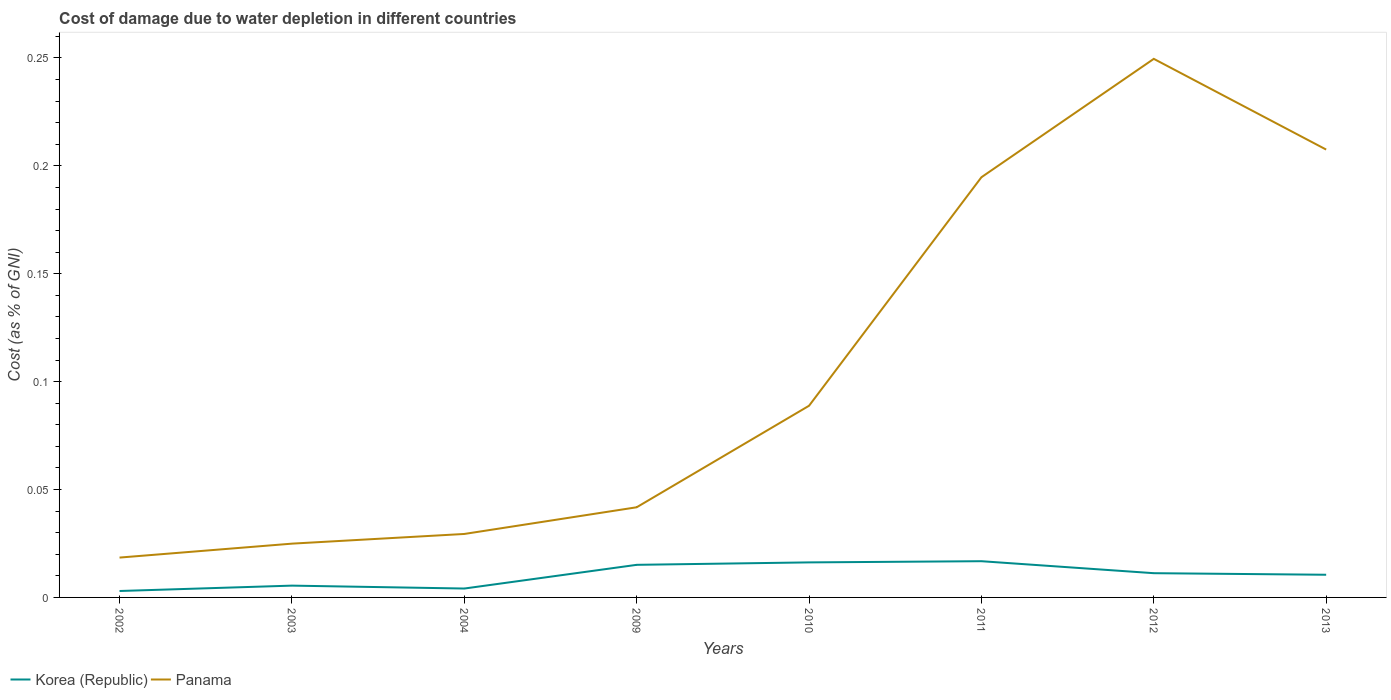How many different coloured lines are there?
Keep it short and to the point. 2. Across all years, what is the maximum cost of damage caused due to water depletion in Korea (Republic)?
Offer a very short reply. 0. What is the total cost of damage caused due to water depletion in Panama in the graph?
Offer a very short reply. -0.12. What is the difference between the highest and the second highest cost of damage caused due to water depletion in Panama?
Give a very brief answer. 0.23. What is the difference between the highest and the lowest cost of damage caused due to water depletion in Panama?
Offer a very short reply. 3. How many lines are there?
Keep it short and to the point. 2. How many years are there in the graph?
Offer a very short reply. 8. What is the difference between two consecutive major ticks on the Y-axis?
Provide a succinct answer. 0.05. Does the graph contain grids?
Make the answer very short. No. Where does the legend appear in the graph?
Provide a succinct answer. Bottom left. What is the title of the graph?
Ensure brevity in your answer.  Cost of damage due to water depletion in different countries. Does "South Asia" appear as one of the legend labels in the graph?
Provide a succinct answer. No. What is the label or title of the X-axis?
Provide a short and direct response. Years. What is the label or title of the Y-axis?
Your answer should be very brief. Cost (as % of GNI). What is the Cost (as % of GNI) in Korea (Republic) in 2002?
Offer a very short reply. 0. What is the Cost (as % of GNI) of Panama in 2002?
Your response must be concise. 0.02. What is the Cost (as % of GNI) in Korea (Republic) in 2003?
Your response must be concise. 0.01. What is the Cost (as % of GNI) of Panama in 2003?
Make the answer very short. 0.02. What is the Cost (as % of GNI) of Korea (Republic) in 2004?
Offer a very short reply. 0. What is the Cost (as % of GNI) in Panama in 2004?
Your answer should be very brief. 0.03. What is the Cost (as % of GNI) in Korea (Republic) in 2009?
Your response must be concise. 0.02. What is the Cost (as % of GNI) in Panama in 2009?
Give a very brief answer. 0.04. What is the Cost (as % of GNI) of Korea (Republic) in 2010?
Give a very brief answer. 0.02. What is the Cost (as % of GNI) in Panama in 2010?
Keep it short and to the point. 0.09. What is the Cost (as % of GNI) in Korea (Republic) in 2011?
Offer a terse response. 0.02. What is the Cost (as % of GNI) in Panama in 2011?
Your answer should be compact. 0.19. What is the Cost (as % of GNI) in Korea (Republic) in 2012?
Keep it short and to the point. 0.01. What is the Cost (as % of GNI) of Panama in 2012?
Provide a succinct answer. 0.25. What is the Cost (as % of GNI) of Korea (Republic) in 2013?
Offer a very short reply. 0.01. What is the Cost (as % of GNI) in Panama in 2013?
Give a very brief answer. 0.21. Across all years, what is the maximum Cost (as % of GNI) of Korea (Republic)?
Keep it short and to the point. 0.02. Across all years, what is the maximum Cost (as % of GNI) of Panama?
Offer a terse response. 0.25. Across all years, what is the minimum Cost (as % of GNI) in Korea (Republic)?
Provide a short and direct response. 0. Across all years, what is the minimum Cost (as % of GNI) in Panama?
Make the answer very short. 0.02. What is the total Cost (as % of GNI) in Korea (Republic) in the graph?
Your answer should be very brief. 0.08. What is the total Cost (as % of GNI) in Panama in the graph?
Give a very brief answer. 0.86. What is the difference between the Cost (as % of GNI) in Korea (Republic) in 2002 and that in 2003?
Your answer should be compact. -0. What is the difference between the Cost (as % of GNI) in Panama in 2002 and that in 2003?
Ensure brevity in your answer.  -0.01. What is the difference between the Cost (as % of GNI) in Korea (Republic) in 2002 and that in 2004?
Ensure brevity in your answer.  -0. What is the difference between the Cost (as % of GNI) in Panama in 2002 and that in 2004?
Provide a short and direct response. -0.01. What is the difference between the Cost (as % of GNI) of Korea (Republic) in 2002 and that in 2009?
Keep it short and to the point. -0.01. What is the difference between the Cost (as % of GNI) in Panama in 2002 and that in 2009?
Provide a short and direct response. -0.02. What is the difference between the Cost (as % of GNI) in Korea (Republic) in 2002 and that in 2010?
Offer a very short reply. -0.01. What is the difference between the Cost (as % of GNI) in Panama in 2002 and that in 2010?
Your answer should be compact. -0.07. What is the difference between the Cost (as % of GNI) in Korea (Republic) in 2002 and that in 2011?
Make the answer very short. -0.01. What is the difference between the Cost (as % of GNI) in Panama in 2002 and that in 2011?
Ensure brevity in your answer.  -0.18. What is the difference between the Cost (as % of GNI) of Korea (Republic) in 2002 and that in 2012?
Keep it short and to the point. -0.01. What is the difference between the Cost (as % of GNI) in Panama in 2002 and that in 2012?
Offer a terse response. -0.23. What is the difference between the Cost (as % of GNI) of Korea (Republic) in 2002 and that in 2013?
Your answer should be very brief. -0.01. What is the difference between the Cost (as % of GNI) in Panama in 2002 and that in 2013?
Offer a terse response. -0.19. What is the difference between the Cost (as % of GNI) of Korea (Republic) in 2003 and that in 2004?
Provide a succinct answer. 0. What is the difference between the Cost (as % of GNI) in Panama in 2003 and that in 2004?
Your answer should be compact. -0. What is the difference between the Cost (as % of GNI) of Korea (Republic) in 2003 and that in 2009?
Offer a terse response. -0.01. What is the difference between the Cost (as % of GNI) in Panama in 2003 and that in 2009?
Ensure brevity in your answer.  -0.02. What is the difference between the Cost (as % of GNI) of Korea (Republic) in 2003 and that in 2010?
Give a very brief answer. -0.01. What is the difference between the Cost (as % of GNI) in Panama in 2003 and that in 2010?
Offer a very short reply. -0.06. What is the difference between the Cost (as % of GNI) in Korea (Republic) in 2003 and that in 2011?
Your answer should be compact. -0.01. What is the difference between the Cost (as % of GNI) in Panama in 2003 and that in 2011?
Your answer should be very brief. -0.17. What is the difference between the Cost (as % of GNI) in Korea (Republic) in 2003 and that in 2012?
Make the answer very short. -0.01. What is the difference between the Cost (as % of GNI) in Panama in 2003 and that in 2012?
Make the answer very short. -0.22. What is the difference between the Cost (as % of GNI) of Korea (Republic) in 2003 and that in 2013?
Give a very brief answer. -0.01. What is the difference between the Cost (as % of GNI) in Panama in 2003 and that in 2013?
Offer a very short reply. -0.18. What is the difference between the Cost (as % of GNI) of Korea (Republic) in 2004 and that in 2009?
Give a very brief answer. -0.01. What is the difference between the Cost (as % of GNI) of Panama in 2004 and that in 2009?
Make the answer very short. -0.01. What is the difference between the Cost (as % of GNI) in Korea (Republic) in 2004 and that in 2010?
Make the answer very short. -0.01. What is the difference between the Cost (as % of GNI) in Panama in 2004 and that in 2010?
Ensure brevity in your answer.  -0.06. What is the difference between the Cost (as % of GNI) of Korea (Republic) in 2004 and that in 2011?
Give a very brief answer. -0.01. What is the difference between the Cost (as % of GNI) of Panama in 2004 and that in 2011?
Provide a short and direct response. -0.17. What is the difference between the Cost (as % of GNI) of Korea (Republic) in 2004 and that in 2012?
Offer a very short reply. -0.01. What is the difference between the Cost (as % of GNI) of Panama in 2004 and that in 2012?
Give a very brief answer. -0.22. What is the difference between the Cost (as % of GNI) in Korea (Republic) in 2004 and that in 2013?
Offer a terse response. -0.01. What is the difference between the Cost (as % of GNI) of Panama in 2004 and that in 2013?
Your answer should be very brief. -0.18. What is the difference between the Cost (as % of GNI) in Korea (Republic) in 2009 and that in 2010?
Offer a terse response. -0. What is the difference between the Cost (as % of GNI) in Panama in 2009 and that in 2010?
Your answer should be very brief. -0.05. What is the difference between the Cost (as % of GNI) in Korea (Republic) in 2009 and that in 2011?
Make the answer very short. -0. What is the difference between the Cost (as % of GNI) in Panama in 2009 and that in 2011?
Your response must be concise. -0.15. What is the difference between the Cost (as % of GNI) of Korea (Republic) in 2009 and that in 2012?
Your answer should be very brief. 0. What is the difference between the Cost (as % of GNI) of Panama in 2009 and that in 2012?
Your response must be concise. -0.21. What is the difference between the Cost (as % of GNI) in Korea (Republic) in 2009 and that in 2013?
Make the answer very short. 0. What is the difference between the Cost (as % of GNI) of Panama in 2009 and that in 2013?
Provide a short and direct response. -0.17. What is the difference between the Cost (as % of GNI) of Korea (Republic) in 2010 and that in 2011?
Give a very brief answer. -0. What is the difference between the Cost (as % of GNI) of Panama in 2010 and that in 2011?
Offer a terse response. -0.11. What is the difference between the Cost (as % of GNI) in Korea (Republic) in 2010 and that in 2012?
Your response must be concise. 0.01. What is the difference between the Cost (as % of GNI) of Panama in 2010 and that in 2012?
Your answer should be compact. -0.16. What is the difference between the Cost (as % of GNI) of Korea (Republic) in 2010 and that in 2013?
Offer a terse response. 0.01. What is the difference between the Cost (as % of GNI) of Panama in 2010 and that in 2013?
Offer a terse response. -0.12. What is the difference between the Cost (as % of GNI) in Korea (Republic) in 2011 and that in 2012?
Ensure brevity in your answer.  0.01. What is the difference between the Cost (as % of GNI) in Panama in 2011 and that in 2012?
Your response must be concise. -0.05. What is the difference between the Cost (as % of GNI) in Korea (Republic) in 2011 and that in 2013?
Offer a terse response. 0.01. What is the difference between the Cost (as % of GNI) in Panama in 2011 and that in 2013?
Offer a terse response. -0.01. What is the difference between the Cost (as % of GNI) of Korea (Republic) in 2012 and that in 2013?
Your answer should be very brief. 0. What is the difference between the Cost (as % of GNI) in Panama in 2012 and that in 2013?
Keep it short and to the point. 0.04. What is the difference between the Cost (as % of GNI) of Korea (Republic) in 2002 and the Cost (as % of GNI) of Panama in 2003?
Give a very brief answer. -0.02. What is the difference between the Cost (as % of GNI) in Korea (Republic) in 2002 and the Cost (as % of GNI) in Panama in 2004?
Ensure brevity in your answer.  -0.03. What is the difference between the Cost (as % of GNI) of Korea (Republic) in 2002 and the Cost (as % of GNI) of Panama in 2009?
Provide a short and direct response. -0.04. What is the difference between the Cost (as % of GNI) in Korea (Republic) in 2002 and the Cost (as % of GNI) in Panama in 2010?
Offer a very short reply. -0.09. What is the difference between the Cost (as % of GNI) of Korea (Republic) in 2002 and the Cost (as % of GNI) of Panama in 2011?
Make the answer very short. -0.19. What is the difference between the Cost (as % of GNI) of Korea (Republic) in 2002 and the Cost (as % of GNI) of Panama in 2012?
Offer a very short reply. -0.25. What is the difference between the Cost (as % of GNI) of Korea (Republic) in 2002 and the Cost (as % of GNI) of Panama in 2013?
Keep it short and to the point. -0.2. What is the difference between the Cost (as % of GNI) of Korea (Republic) in 2003 and the Cost (as % of GNI) of Panama in 2004?
Your response must be concise. -0.02. What is the difference between the Cost (as % of GNI) of Korea (Republic) in 2003 and the Cost (as % of GNI) of Panama in 2009?
Offer a very short reply. -0.04. What is the difference between the Cost (as % of GNI) in Korea (Republic) in 2003 and the Cost (as % of GNI) in Panama in 2010?
Keep it short and to the point. -0.08. What is the difference between the Cost (as % of GNI) of Korea (Republic) in 2003 and the Cost (as % of GNI) of Panama in 2011?
Provide a short and direct response. -0.19. What is the difference between the Cost (as % of GNI) in Korea (Republic) in 2003 and the Cost (as % of GNI) in Panama in 2012?
Give a very brief answer. -0.24. What is the difference between the Cost (as % of GNI) in Korea (Republic) in 2003 and the Cost (as % of GNI) in Panama in 2013?
Ensure brevity in your answer.  -0.2. What is the difference between the Cost (as % of GNI) of Korea (Republic) in 2004 and the Cost (as % of GNI) of Panama in 2009?
Provide a short and direct response. -0.04. What is the difference between the Cost (as % of GNI) in Korea (Republic) in 2004 and the Cost (as % of GNI) in Panama in 2010?
Your answer should be very brief. -0.08. What is the difference between the Cost (as % of GNI) in Korea (Republic) in 2004 and the Cost (as % of GNI) in Panama in 2011?
Your answer should be compact. -0.19. What is the difference between the Cost (as % of GNI) in Korea (Republic) in 2004 and the Cost (as % of GNI) in Panama in 2012?
Provide a succinct answer. -0.25. What is the difference between the Cost (as % of GNI) of Korea (Republic) in 2004 and the Cost (as % of GNI) of Panama in 2013?
Offer a very short reply. -0.2. What is the difference between the Cost (as % of GNI) in Korea (Republic) in 2009 and the Cost (as % of GNI) in Panama in 2010?
Your answer should be compact. -0.07. What is the difference between the Cost (as % of GNI) in Korea (Republic) in 2009 and the Cost (as % of GNI) in Panama in 2011?
Make the answer very short. -0.18. What is the difference between the Cost (as % of GNI) of Korea (Republic) in 2009 and the Cost (as % of GNI) of Panama in 2012?
Provide a succinct answer. -0.23. What is the difference between the Cost (as % of GNI) in Korea (Republic) in 2009 and the Cost (as % of GNI) in Panama in 2013?
Offer a very short reply. -0.19. What is the difference between the Cost (as % of GNI) in Korea (Republic) in 2010 and the Cost (as % of GNI) in Panama in 2011?
Ensure brevity in your answer.  -0.18. What is the difference between the Cost (as % of GNI) in Korea (Republic) in 2010 and the Cost (as % of GNI) in Panama in 2012?
Make the answer very short. -0.23. What is the difference between the Cost (as % of GNI) in Korea (Republic) in 2010 and the Cost (as % of GNI) in Panama in 2013?
Provide a short and direct response. -0.19. What is the difference between the Cost (as % of GNI) of Korea (Republic) in 2011 and the Cost (as % of GNI) of Panama in 2012?
Make the answer very short. -0.23. What is the difference between the Cost (as % of GNI) in Korea (Republic) in 2011 and the Cost (as % of GNI) in Panama in 2013?
Your answer should be very brief. -0.19. What is the difference between the Cost (as % of GNI) in Korea (Republic) in 2012 and the Cost (as % of GNI) in Panama in 2013?
Give a very brief answer. -0.2. What is the average Cost (as % of GNI) of Korea (Republic) per year?
Your answer should be compact. 0.01. What is the average Cost (as % of GNI) of Panama per year?
Make the answer very short. 0.11. In the year 2002, what is the difference between the Cost (as % of GNI) of Korea (Republic) and Cost (as % of GNI) of Panama?
Offer a very short reply. -0.02. In the year 2003, what is the difference between the Cost (as % of GNI) in Korea (Republic) and Cost (as % of GNI) in Panama?
Ensure brevity in your answer.  -0.02. In the year 2004, what is the difference between the Cost (as % of GNI) in Korea (Republic) and Cost (as % of GNI) in Panama?
Keep it short and to the point. -0.03. In the year 2009, what is the difference between the Cost (as % of GNI) in Korea (Republic) and Cost (as % of GNI) in Panama?
Make the answer very short. -0.03. In the year 2010, what is the difference between the Cost (as % of GNI) of Korea (Republic) and Cost (as % of GNI) of Panama?
Provide a short and direct response. -0.07. In the year 2011, what is the difference between the Cost (as % of GNI) of Korea (Republic) and Cost (as % of GNI) of Panama?
Your answer should be compact. -0.18. In the year 2012, what is the difference between the Cost (as % of GNI) of Korea (Republic) and Cost (as % of GNI) of Panama?
Ensure brevity in your answer.  -0.24. In the year 2013, what is the difference between the Cost (as % of GNI) of Korea (Republic) and Cost (as % of GNI) of Panama?
Keep it short and to the point. -0.2. What is the ratio of the Cost (as % of GNI) in Korea (Republic) in 2002 to that in 2003?
Offer a very short reply. 0.55. What is the ratio of the Cost (as % of GNI) of Panama in 2002 to that in 2003?
Offer a terse response. 0.74. What is the ratio of the Cost (as % of GNI) of Korea (Republic) in 2002 to that in 2004?
Make the answer very short. 0.72. What is the ratio of the Cost (as % of GNI) in Panama in 2002 to that in 2004?
Give a very brief answer. 0.63. What is the ratio of the Cost (as % of GNI) in Korea (Republic) in 2002 to that in 2009?
Make the answer very short. 0.2. What is the ratio of the Cost (as % of GNI) of Panama in 2002 to that in 2009?
Give a very brief answer. 0.44. What is the ratio of the Cost (as % of GNI) of Korea (Republic) in 2002 to that in 2010?
Your response must be concise. 0.18. What is the ratio of the Cost (as % of GNI) in Panama in 2002 to that in 2010?
Give a very brief answer. 0.21. What is the ratio of the Cost (as % of GNI) in Korea (Republic) in 2002 to that in 2011?
Your response must be concise. 0.18. What is the ratio of the Cost (as % of GNI) in Panama in 2002 to that in 2011?
Provide a succinct answer. 0.09. What is the ratio of the Cost (as % of GNI) in Korea (Republic) in 2002 to that in 2012?
Your response must be concise. 0.27. What is the ratio of the Cost (as % of GNI) of Panama in 2002 to that in 2012?
Your answer should be very brief. 0.07. What is the ratio of the Cost (as % of GNI) in Korea (Republic) in 2002 to that in 2013?
Offer a terse response. 0.28. What is the ratio of the Cost (as % of GNI) in Panama in 2002 to that in 2013?
Your answer should be compact. 0.09. What is the ratio of the Cost (as % of GNI) of Korea (Republic) in 2003 to that in 2004?
Your answer should be compact. 1.33. What is the ratio of the Cost (as % of GNI) in Panama in 2003 to that in 2004?
Your response must be concise. 0.85. What is the ratio of the Cost (as % of GNI) of Korea (Republic) in 2003 to that in 2009?
Your answer should be compact. 0.36. What is the ratio of the Cost (as % of GNI) of Panama in 2003 to that in 2009?
Keep it short and to the point. 0.6. What is the ratio of the Cost (as % of GNI) of Korea (Republic) in 2003 to that in 2010?
Keep it short and to the point. 0.34. What is the ratio of the Cost (as % of GNI) in Panama in 2003 to that in 2010?
Your answer should be very brief. 0.28. What is the ratio of the Cost (as % of GNI) of Korea (Republic) in 2003 to that in 2011?
Offer a very short reply. 0.33. What is the ratio of the Cost (as % of GNI) of Panama in 2003 to that in 2011?
Your answer should be very brief. 0.13. What is the ratio of the Cost (as % of GNI) in Korea (Republic) in 2003 to that in 2012?
Give a very brief answer. 0.49. What is the ratio of the Cost (as % of GNI) of Panama in 2003 to that in 2012?
Offer a very short reply. 0.1. What is the ratio of the Cost (as % of GNI) of Korea (Republic) in 2003 to that in 2013?
Provide a short and direct response. 0.52. What is the ratio of the Cost (as % of GNI) of Panama in 2003 to that in 2013?
Provide a succinct answer. 0.12. What is the ratio of the Cost (as % of GNI) of Korea (Republic) in 2004 to that in 2009?
Offer a terse response. 0.27. What is the ratio of the Cost (as % of GNI) in Panama in 2004 to that in 2009?
Offer a terse response. 0.7. What is the ratio of the Cost (as % of GNI) of Korea (Republic) in 2004 to that in 2010?
Ensure brevity in your answer.  0.25. What is the ratio of the Cost (as % of GNI) of Panama in 2004 to that in 2010?
Your response must be concise. 0.33. What is the ratio of the Cost (as % of GNI) of Korea (Republic) in 2004 to that in 2011?
Make the answer very short. 0.25. What is the ratio of the Cost (as % of GNI) in Panama in 2004 to that in 2011?
Offer a very short reply. 0.15. What is the ratio of the Cost (as % of GNI) of Korea (Republic) in 2004 to that in 2012?
Give a very brief answer. 0.37. What is the ratio of the Cost (as % of GNI) of Panama in 2004 to that in 2012?
Keep it short and to the point. 0.12. What is the ratio of the Cost (as % of GNI) of Korea (Republic) in 2004 to that in 2013?
Offer a terse response. 0.39. What is the ratio of the Cost (as % of GNI) of Panama in 2004 to that in 2013?
Give a very brief answer. 0.14. What is the ratio of the Cost (as % of GNI) of Korea (Republic) in 2009 to that in 2010?
Offer a very short reply. 0.93. What is the ratio of the Cost (as % of GNI) of Panama in 2009 to that in 2010?
Offer a terse response. 0.47. What is the ratio of the Cost (as % of GNI) in Korea (Republic) in 2009 to that in 2011?
Offer a terse response. 0.9. What is the ratio of the Cost (as % of GNI) in Panama in 2009 to that in 2011?
Your response must be concise. 0.21. What is the ratio of the Cost (as % of GNI) of Korea (Republic) in 2009 to that in 2012?
Your answer should be compact. 1.34. What is the ratio of the Cost (as % of GNI) in Panama in 2009 to that in 2012?
Ensure brevity in your answer.  0.17. What is the ratio of the Cost (as % of GNI) of Korea (Republic) in 2009 to that in 2013?
Offer a terse response. 1.44. What is the ratio of the Cost (as % of GNI) of Panama in 2009 to that in 2013?
Give a very brief answer. 0.2. What is the ratio of the Cost (as % of GNI) of Korea (Republic) in 2010 to that in 2011?
Give a very brief answer. 0.97. What is the ratio of the Cost (as % of GNI) of Panama in 2010 to that in 2011?
Offer a terse response. 0.46. What is the ratio of the Cost (as % of GNI) of Korea (Republic) in 2010 to that in 2012?
Ensure brevity in your answer.  1.44. What is the ratio of the Cost (as % of GNI) in Panama in 2010 to that in 2012?
Offer a very short reply. 0.36. What is the ratio of the Cost (as % of GNI) of Korea (Republic) in 2010 to that in 2013?
Provide a succinct answer. 1.54. What is the ratio of the Cost (as % of GNI) of Panama in 2010 to that in 2013?
Make the answer very short. 0.43. What is the ratio of the Cost (as % of GNI) of Korea (Republic) in 2011 to that in 2012?
Provide a short and direct response. 1.49. What is the ratio of the Cost (as % of GNI) of Panama in 2011 to that in 2012?
Provide a short and direct response. 0.78. What is the ratio of the Cost (as % of GNI) of Korea (Republic) in 2011 to that in 2013?
Offer a terse response. 1.6. What is the ratio of the Cost (as % of GNI) of Panama in 2011 to that in 2013?
Make the answer very short. 0.94. What is the ratio of the Cost (as % of GNI) of Korea (Republic) in 2012 to that in 2013?
Ensure brevity in your answer.  1.07. What is the ratio of the Cost (as % of GNI) in Panama in 2012 to that in 2013?
Offer a terse response. 1.2. What is the difference between the highest and the second highest Cost (as % of GNI) in Korea (Republic)?
Keep it short and to the point. 0. What is the difference between the highest and the second highest Cost (as % of GNI) in Panama?
Provide a short and direct response. 0.04. What is the difference between the highest and the lowest Cost (as % of GNI) of Korea (Republic)?
Offer a terse response. 0.01. What is the difference between the highest and the lowest Cost (as % of GNI) of Panama?
Your answer should be very brief. 0.23. 